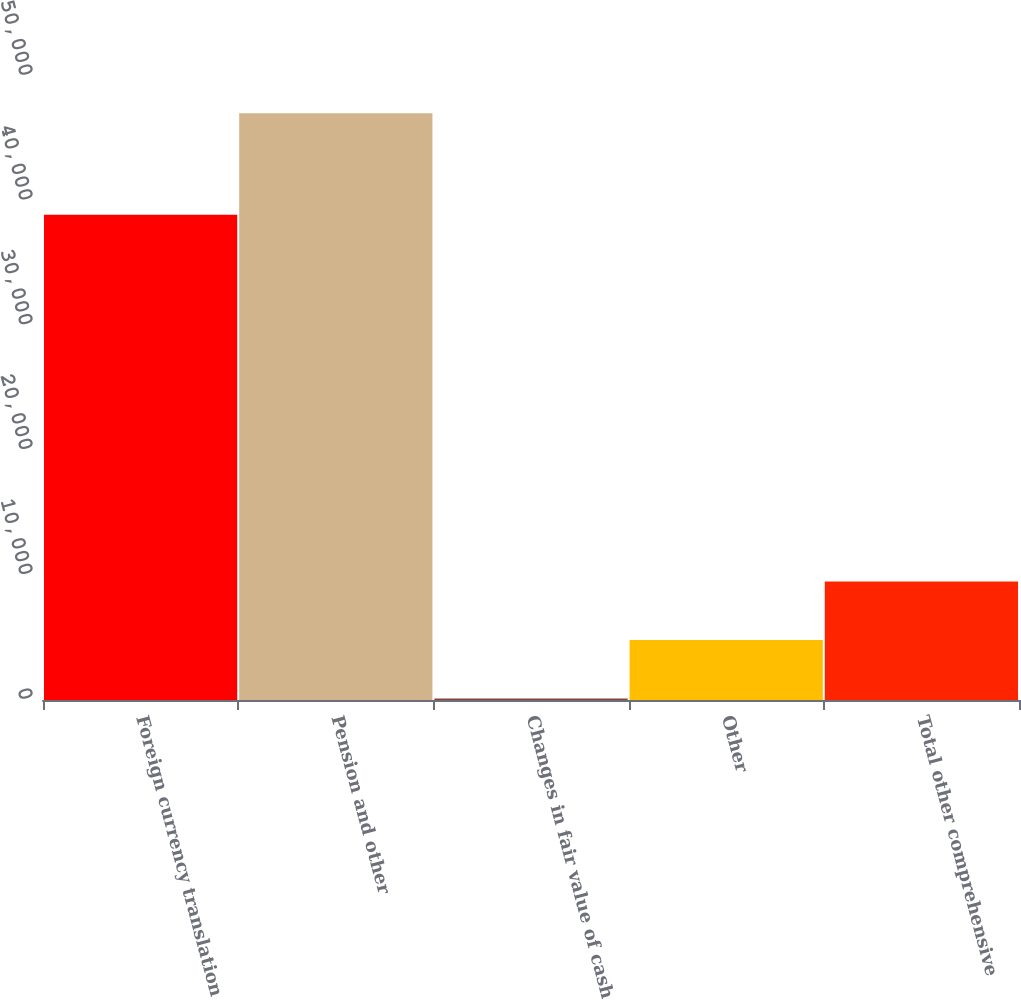<chart> <loc_0><loc_0><loc_500><loc_500><bar_chart><fcel>Foreign currency translation<fcel>Pension and other<fcel>Changes in fair value of cash<fcel>Other<fcel>Total other comprehensive<nl><fcel>38880<fcel>47010<fcel>125<fcel>4813.5<fcel>9502<nl></chart> 